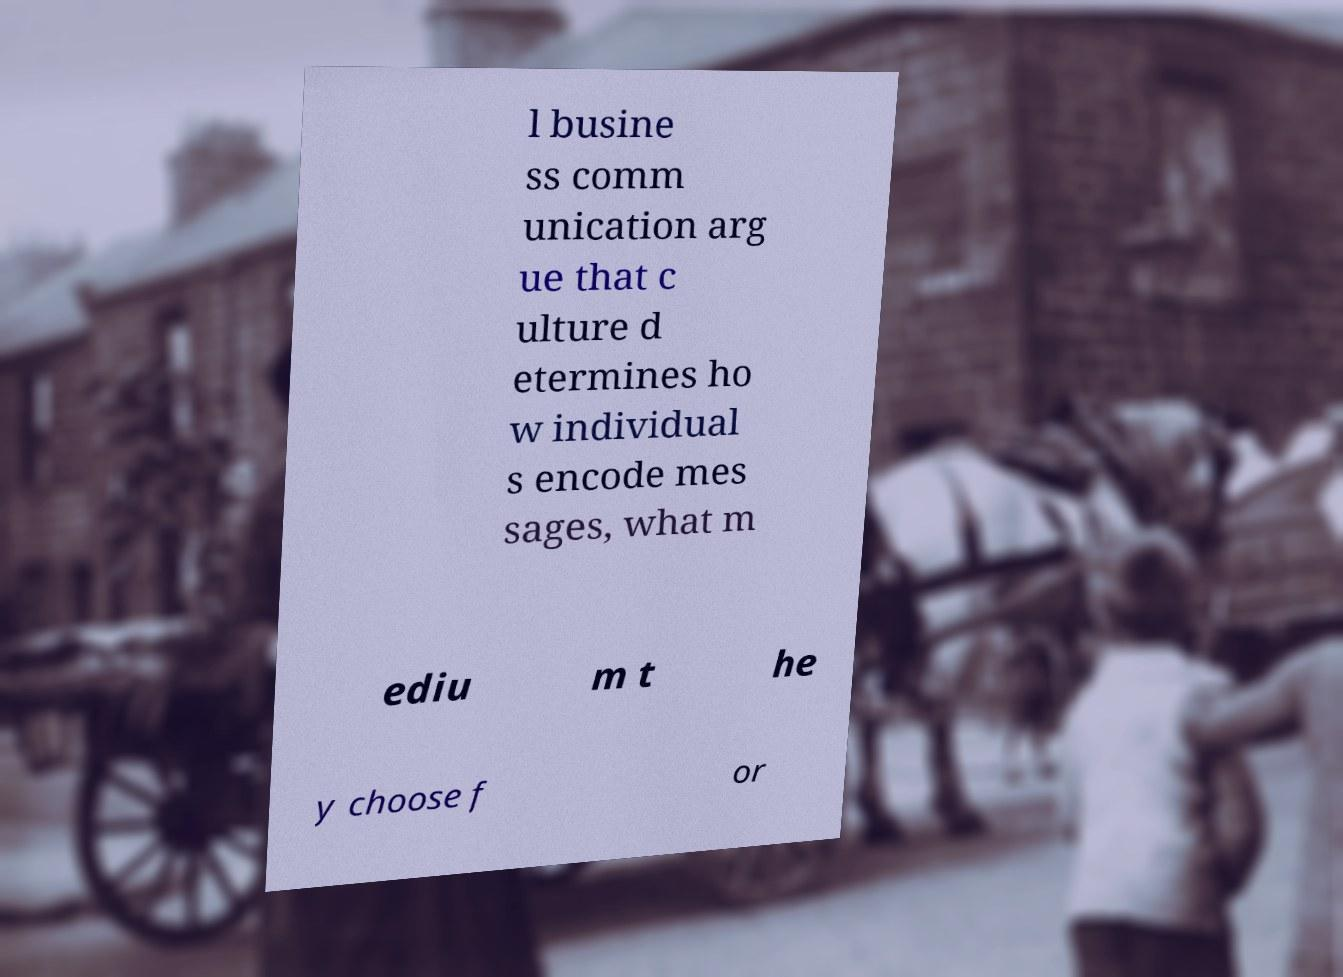Can you accurately transcribe the text from the provided image for me? l busine ss comm unication arg ue that c ulture d etermines ho w individual s encode mes sages, what m ediu m t he y choose f or 